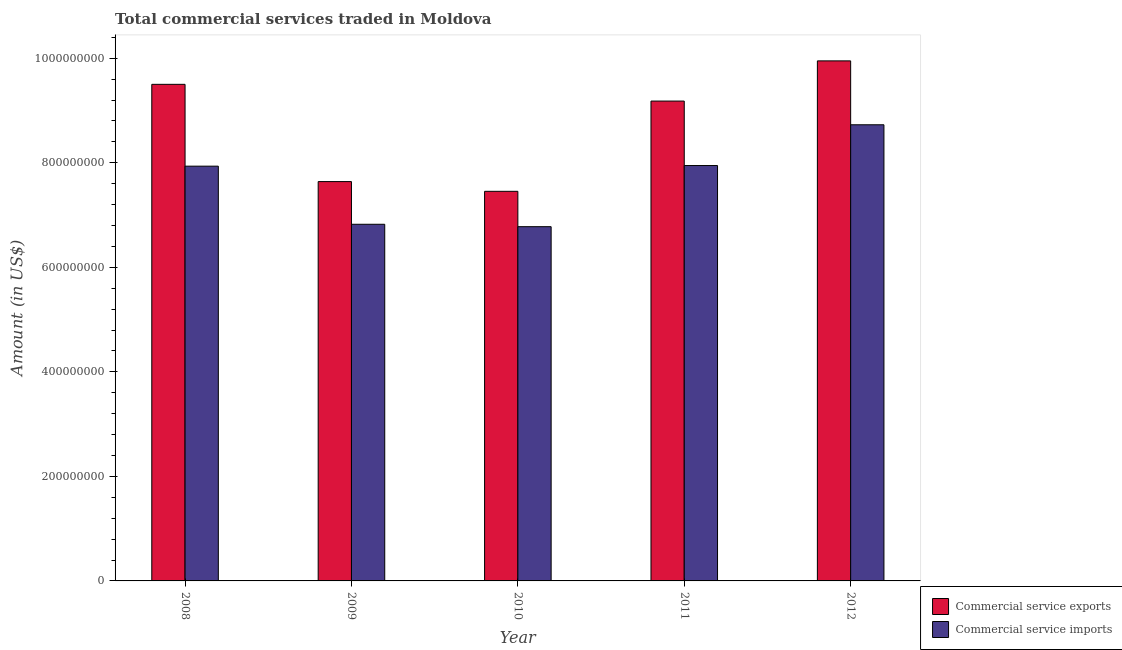How many different coloured bars are there?
Give a very brief answer. 2. How many groups of bars are there?
Offer a terse response. 5. How many bars are there on the 4th tick from the left?
Provide a short and direct response. 2. How many bars are there on the 4th tick from the right?
Your response must be concise. 2. What is the amount of commercial service imports in 2008?
Your answer should be very brief. 7.94e+08. Across all years, what is the maximum amount of commercial service exports?
Provide a succinct answer. 9.95e+08. Across all years, what is the minimum amount of commercial service exports?
Keep it short and to the point. 7.45e+08. In which year was the amount of commercial service imports minimum?
Offer a very short reply. 2010. What is the total amount of commercial service exports in the graph?
Keep it short and to the point. 4.37e+09. What is the difference between the amount of commercial service imports in 2008 and that in 2011?
Provide a succinct answer. -1.20e+06. What is the difference between the amount of commercial service exports in 2011 and the amount of commercial service imports in 2009?
Provide a succinct answer. 1.54e+08. What is the average amount of commercial service imports per year?
Provide a succinct answer. 7.64e+08. In the year 2010, what is the difference between the amount of commercial service imports and amount of commercial service exports?
Your answer should be very brief. 0. In how many years, is the amount of commercial service imports greater than 280000000 US$?
Your response must be concise. 5. What is the ratio of the amount of commercial service imports in 2010 to that in 2011?
Provide a short and direct response. 0.85. What is the difference between the highest and the second highest amount of commercial service exports?
Provide a short and direct response. 4.49e+07. What is the difference between the highest and the lowest amount of commercial service imports?
Your answer should be compact. 1.95e+08. What does the 2nd bar from the left in 2011 represents?
Your answer should be very brief. Commercial service imports. What does the 1st bar from the right in 2008 represents?
Offer a very short reply. Commercial service imports. Are all the bars in the graph horizontal?
Provide a succinct answer. No. What is the difference between two consecutive major ticks on the Y-axis?
Your answer should be compact. 2.00e+08. How are the legend labels stacked?
Ensure brevity in your answer.  Vertical. What is the title of the graph?
Offer a terse response. Total commercial services traded in Moldova. Does "Male labourers" appear as one of the legend labels in the graph?
Offer a terse response. No. What is the label or title of the Y-axis?
Offer a terse response. Amount (in US$). What is the Amount (in US$) of Commercial service exports in 2008?
Provide a short and direct response. 9.50e+08. What is the Amount (in US$) in Commercial service imports in 2008?
Ensure brevity in your answer.  7.94e+08. What is the Amount (in US$) in Commercial service exports in 2009?
Offer a very short reply. 7.64e+08. What is the Amount (in US$) of Commercial service imports in 2009?
Offer a terse response. 6.82e+08. What is the Amount (in US$) of Commercial service exports in 2010?
Give a very brief answer. 7.45e+08. What is the Amount (in US$) of Commercial service imports in 2010?
Give a very brief answer. 6.78e+08. What is the Amount (in US$) of Commercial service exports in 2011?
Give a very brief answer. 9.18e+08. What is the Amount (in US$) of Commercial service imports in 2011?
Provide a succinct answer. 7.95e+08. What is the Amount (in US$) of Commercial service exports in 2012?
Give a very brief answer. 9.95e+08. What is the Amount (in US$) in Commercial service imports in 2012?
Ensure brevity in your answer.  8.73e+08. Across all years, what is the maximum Amount (in US$) of Commercial service exports?
Keep it short and to the point. 9.95e+08. Across all years, what is the maximum Amount (in US$) of Commercial service imports?
Give a very brief answer. 8.73e+08. Across all years, what is the minimum Amount (in US$) of Commercial service exports?
Provide a succinct answer. 7.45e+08. Across all years, what is the minimum Amount (in US$) of Commercial service imports?
Your answer should be compact. 6.78e+08. What is the total Amount (in US$) in Commercial service exports in the graph?
Ensure brevity in your answer.  4.37e+09. What is the total Amount (in US$) of Commercial service imports in the graph?
Offer a terse response. 3.82e+09. What is the difference between the Amount (in US$) of Commercial service exports in 2008 and that in 2009?
Provide a short and direct response. 1.86e+08. What is the difference between the Amount (in US$) of Commercial service imports in 2008 and that in 2009?
Your answer should be very brief. 1.11e+08. What is the difference between the Amount (in US$) of Commercial service exports in 2008 and that in 2010?
Offer a very short reply. 2.05e+08. What is the difference between the Amount (in US$) in Commercial service imports in 2008 and that in 2010?
Offer a very short reply. 1.16e+08. What is the difference between the Amount (in US$) in Commercial service exports in 2008 and that in 2011?
Offer a very short reply. 3.20e+07. What is the difference between the Amount (in US$) of Commercial service imports in 2008 and that in 2011?
Your answer should be very brief. -1.20e+06. What is the difference between the Amount (in US$) in Commercial service exports in 2008 and that in 2012?
Offer a very short reply. -4.49e+07. What is the difference between the Amount (in US$) of Commercial service imports in 2008 and that in 2012?
Make the answer very short. -7.92e+07. What is the difference between the Amount (in US$) in Commercial service exports in 2009 and that in 2010?
Your answer should be compact. 1.86e+07. What is the difference between the Amount (in US$) of Commercial service imports in 2009 and that in 2010?
Offer a terse response. 4.61e+06. What is the difference between the Amount (in US$) in Commercial service exports in 2009 and that in 2011?
Your answer should be compact. -1.54e+08. What is the difference between the Amount (in US$) of Commercial service imports in 2009 and that in 2011?
Provide a succinct answer. -1.12e+08. What is the difference between the Amount (in US$) in Commercial service exports in 2009 and that in 2012?
Make the answer very short. -2.31e+08. What is the difference between the Amount (in US$) of Commercial service imports in 2009 and that in 2012?
Your answer should be compact. -1.90e+08. What is the difference between the Amount (in US$) in Commercial service exports in 2010 and that in 2011?
Offer a terse response. -1.73e+08. What is the difference between the Amount (in US$) of Commercial service imports in 2010 and that in 2011?
Provide a succinct answer. -1.17e+08. What is the difference between the Amount (in US$) in Commercial service exports in 2010 and that in 2012?
Keep it short and to the point. -2.50e+08. What is the difference between the Amount (in US$) of Commercial service imports in 2010 and that in 2012?
Your answer should be compact. -1.95e+08. What is the difference between the Amount (in US$) in Commercial service exports in 2011 and that in 2012?
Give a very brief answer. -7.69e+07. What is the difference between the Amount (in US$) in Commercial service imports in 2011 and that in 2012?
Provide a succinct answer. -7.80e+07. What is the difference between the Amount (in US$) of Commercial service exports in 2008 and the Amount (in US$) of Commercial service imports in 2009?
Keep it short and to the point. 2.68e+08. What is the difference between the Amount (in US$) in Commercial service exports in 2008 and the Amount (in US$) in Commercial service imports in 2010?
Your response must be concise. 2.72e+08. What is the difference between the Amount (in US$) of Commercial service exports in 2008 and the Amount (in US$) of Commercial service imports in 2011?
Provide a succinct answer. 1.55e+08. What is the difference between the Amount (in US$) in Commercial service exports in 2008 and the Amount (in US$) in Commercial service imports in 2012?
Offer a terse response. 7.74e+07. What is the difference between the Amount (in US$) in Commercial service exports in 2009 and the Amount (in US$) in Commercial service imports in 2010?
Your response must be concise. 8.63e+07. What is the difference between the Amount (in US$) of Commercial service exports in 2009 and the Amount (in US$) of Commercial service imports in 2011?
Provide a short and direct response. -3.07e+07. What is the difference between the Amount (in US$) of Commercial service exports in 2009 and the Amount (in US$) of Commercial service imports in 2012?
Offer a terse response. -1.09e+08. What is the difference between the Amount (in US$) of Commercial service exports in 2010 and the Amount (in US$) of Commercial service imports in 2011?
Give a very brief answer. -4.93e+07. What is the difference between the Amount (in US$) of Commercial service exports in 2010 and the Amount (in US$) of Commercial service imports in 2012?
Your response must be concise. -1.27e+08. What is the difference between the Amount (in US$) of Commercial service exports in 2011 and the Amount (in US$) of Commercial service imports in 2012?
Make the answer very short. 4.53e+07. What is the average Amount (in US$) of Commercial service exports per year?
Keep it short and to the point. 8.74e+08. What is the average Amount (in US$) in Commercial service imports per year?
Make the answer very short. 7.64e+08. In the year 2008, what is the difference between the Amount (in US$) of Commercial service exports and Amount (in US$) of Commercial service imports?
Provide a short and direct response. 1.57e+08. In the year 2009, what is the difference between the Amount (in US$) in Commercial service exports and Amount (in US$) in Commercial service imports?
Provide a succinct answer. 8.17e+07. In the year 2010, what is the difference between the Amount (in US$) in Commercial service exports and Amount (in US$) in Commercial service imports?
Provide a succinct answer. 6.76e+07. In the year 2011, what is the difference between the Amount (in US$) of Commercial service exports and Amount (in US$) of Commercial service imports?
Your answer should be compact. 1.23e+08. In the year 2012, what is the difference between the Amount (in US$) of Commercial service exports and Amount (in US$) of Commercial service imports?
Make the answer very short. 1.22e+08. What is the ratio of the Amount (in US$) in Commercial service exports in 2008 to that in 2009?
Make the answer very short. 1.24. What is the ratio of the Amount (in US$) of Commercial service imports in 2008 to that in 2009?
Provide a succinct answer. 1.16. What is the ratio of the Amount (in US$) in Commercial service exports in 2008 to that in 2010?
Ensure brevity in your answer.  1.27. What is the ratio of the Amount (in US$) of Commercial service imports in 2008 to that in 2010?
Offer a very short reply. 1.17. What is the ratio of the Amount (in US$) of Commercial service exports in 2008 to that in 2011?
Your answer should be very brief. 1.03. What is the ratio of the Amount (in US$) of Commercial service exports in 2008 to that in 2012?
Provide a short and direct response. 0.95. What is the ratio of the Amount (in US$) of Commercial service imports in 2008 to that in 2012?
Provide a succinct answer. 0.91. What is the ratio of the Amount (in US$) of Commercial service imports in 2009 to that in 2010?
Ensure brevity in your answer.  1.01. What is the ratio of the Amount (in US$) in Commercial service exports in 2009 to that in 2011?
Keep it short and to the point. 0.83. What is the ratio of the Amount (in US$) of Commercial service imports in 2009 to that in 2011?
Your answer should be compact. 0.86. What is the ratio of the Amount (in US$) of Commercial service exports in 2009 to that in 2012?
Make the answer very short. 0.77. What is the ratio of the Amount (in US$) in Commercial service imports in 2009 to that in 2012?
Your answer should be very brief. 0.78. What is the ratio of the Amount (in US$) of Commercial service exports in 2010 to that in 2011?
Provide a short and direct response. 0.81. What is the ratio of the Amount (in US$) of Commercial service imports in 2010 to that in 2011?
Provide a short and direct response. 0.85. What is the ratio of the Amount (in US$) of Commercial service exports in 2010 to that in 2012?
Your answer should be compact. 0.75. What is the ratio of the Amount (in US$) of Commercial service imports in 2010 to that in 2012?
Your response must be concise. 0.78. What is the ratio of the Amount (in US$) in Commercial service exports in 2011 to that in 2012?
Offer a terse response. 0.92. What is the ratio of the Amount (in US$) in Commercial service imports in 2011 to that in 2012?
Offer a very short reply. 0.91. What is the difference between the highest and the second highest Amount (in US$) of Commercial service exports?
Give a very brief answer. 4.49e+07. What is the difference between the highest and the second highest Amount (in US$) of Commercial service imports?
Offer a very short reply. 7.80e+07. What is the difference between the highest and the lowest Amount (in US$) of Commercial service exports?
Give a very brief answer. 2.50e+08. What is the difference between the highest and the lowest Amount (in US$) in Commercial service imports?
Give a very brief answer. 1.95e+08. 